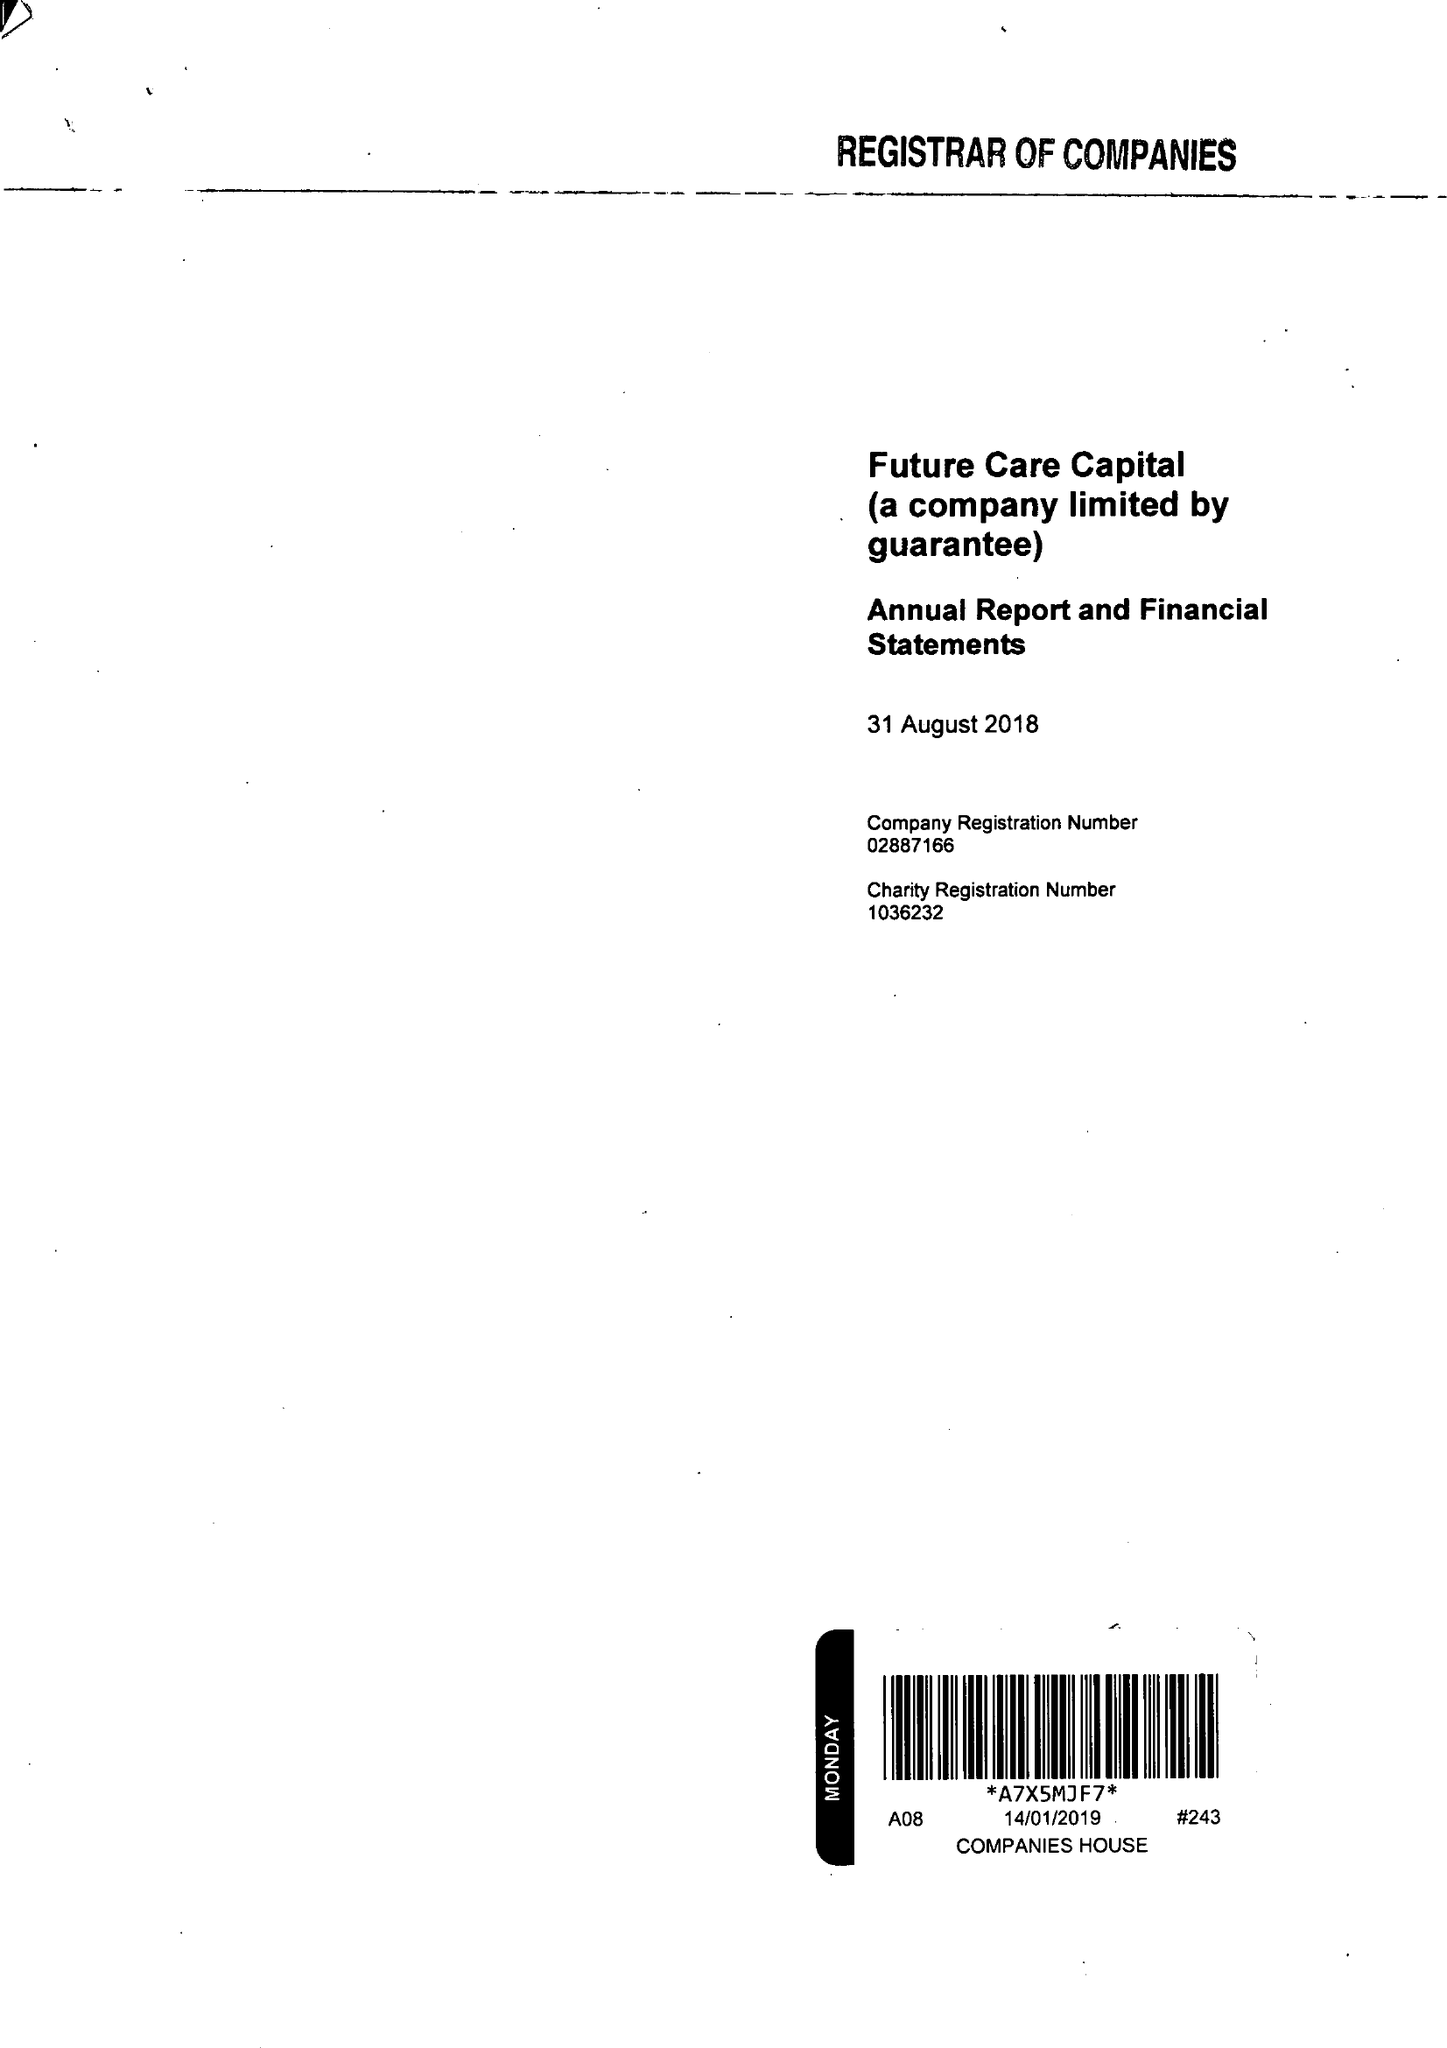What is the value for the charity_name?
Answer the question using a single word or phrase. Future Care Capital 